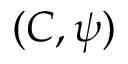<formula> <loc_0><loc_0><loc_500><loc_500>( C , \psi )</formula> 